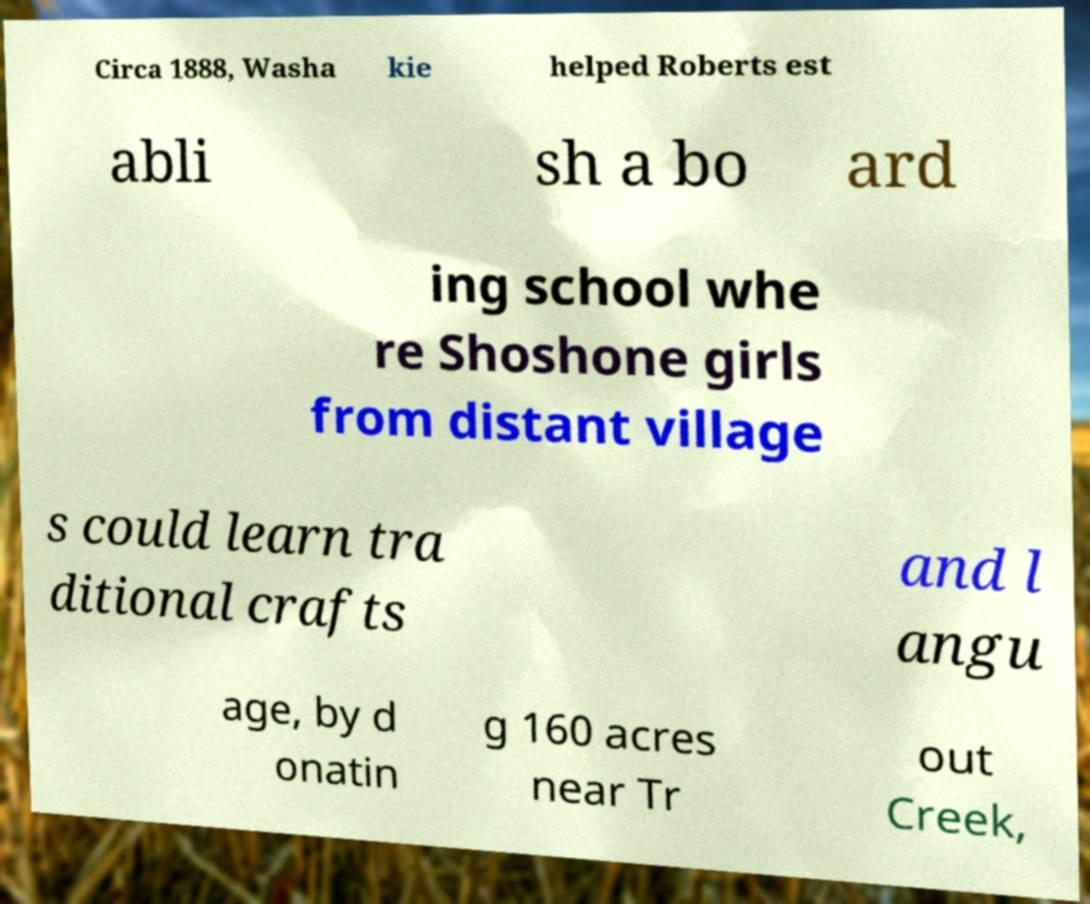Could you assist in decoding the text presented in this image and type it out clearly? Circa 1888, Washa kie helped Roberts est abli sh a bo ard ing school whe re Shoshone girls from distant village s could learn tra ditional crafts and l angu age, by d onatin g 160 acres near Tr out Creek, 